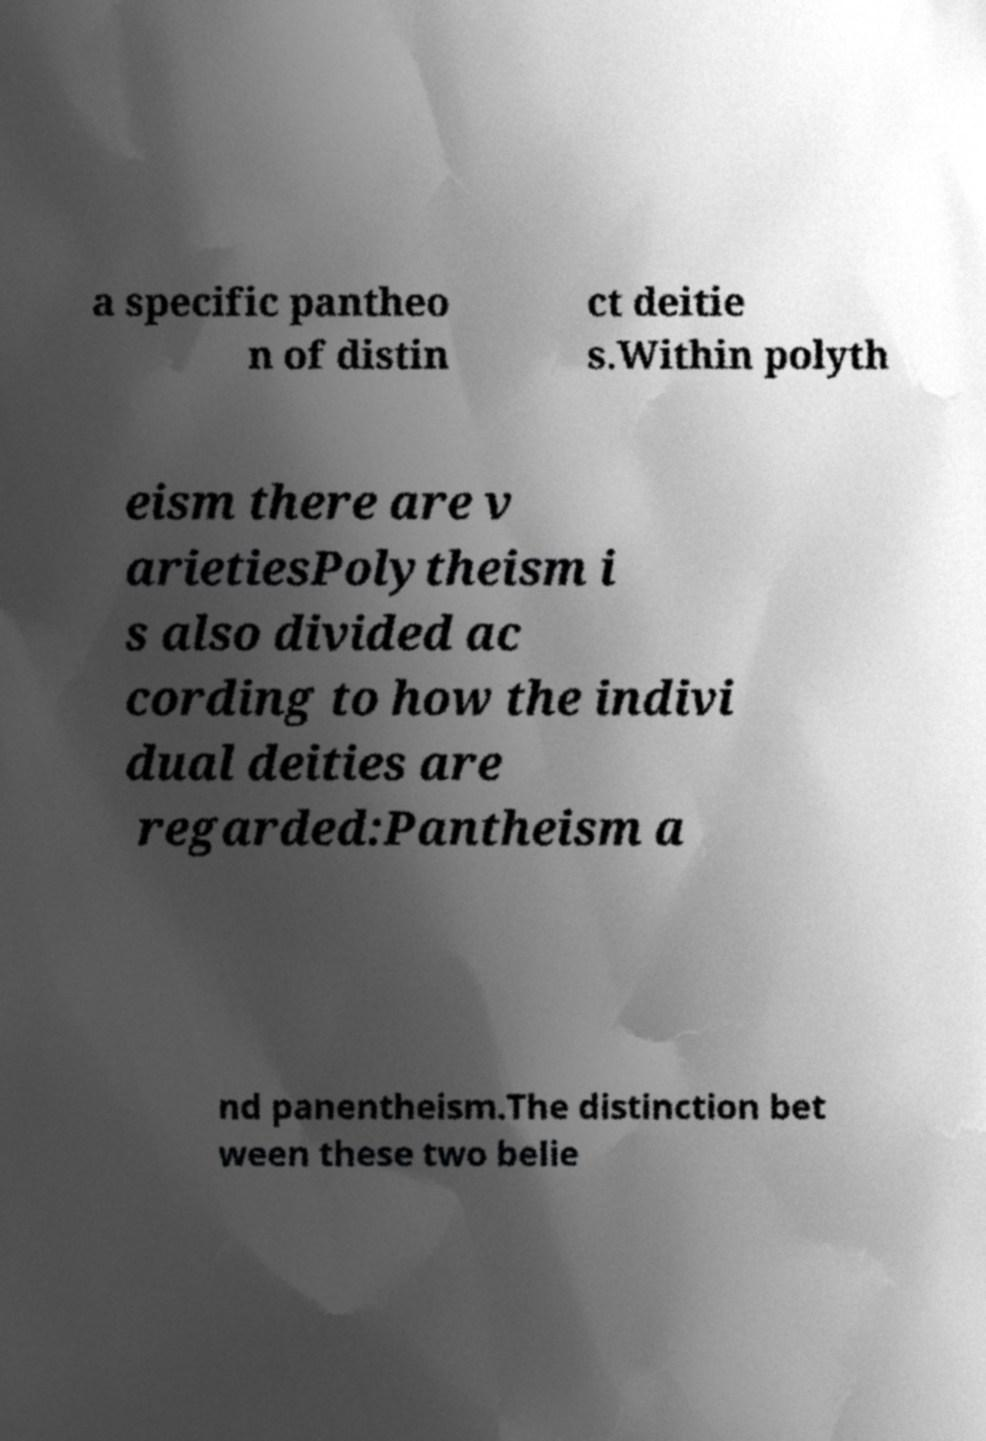Could you assist in decoding the text presented in this image and type it out clearly? a specific pantheo n of distin ct deitie s.Within polyth eism there are v arietiesPolytheism i s also divided ac cording to how the indivi dual deities are regarded:Pantheism a nd panentheism.The distinction bet ween these two belie 